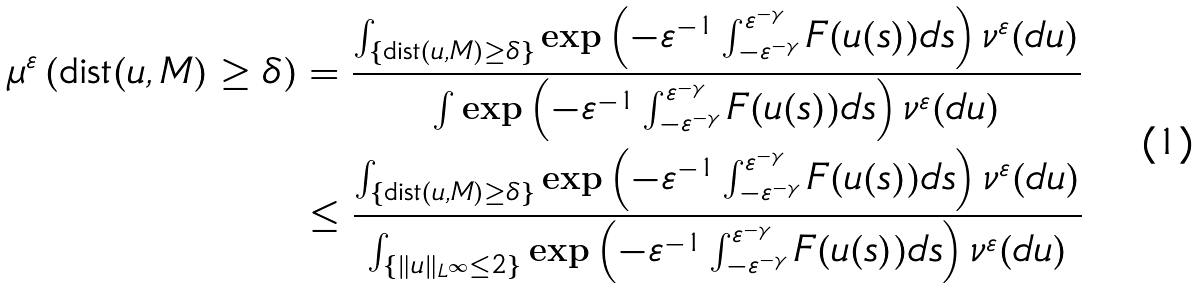Convert formula to latex. <formula><loc_0><loc_0><loc_500><loc_500>\mu ^ { \varepsilon } \left ( \text {dist} ( u , M ) \geq \delta \right ) & = \frac { \int _ { \{ \text {dist} ( u , M ) \geq \delta \} } \exp \left ( - \varepsilon ^ { - 1 } \int _ { - \varepsilon ^ { - \gamma } } ^ { \varepsilon ^ { - \gamma } } F ( u ( s ) ) d s \right ) \nu ^ { \varepsilon } ( d u ) } { \int \exp \left ( - \varepsilon ^ { - 1 } \int _ { - \varepsilon ^ { - \gamma } } ^ { \varepsilon ^ { - \gamma } } F ( u ( s ) ) d s \right ) \nu ^ { \varepsilon } ( d u ) } \\ & \leq \frac { \int _ { \{ \text {dist} ( u , M ) \geq \delta \} } \exp \left ( - \varepsilon ^ { - 1 } \int _ { - \varepsilon ^ { - \gamma } } ^ { \varepsilon ^ { - \gamma } } F ( u ( s ) ) d s \right ) \nu ^ { \varepsilon } ( d u ) } { \int _ { \{ \| u \| _ { L ^ { \infty } } \leq 2 \} } \exp \left ( - \varepsilon ^ { - 1 } \int _ { - \varepsilon ^ { - \gamma } } ^ { \varepsilon ^ { - \gamma } } F ( u ( s ) ) d s \right ) \nu ^ { \varepsilon } ( d u ) }</formula> 